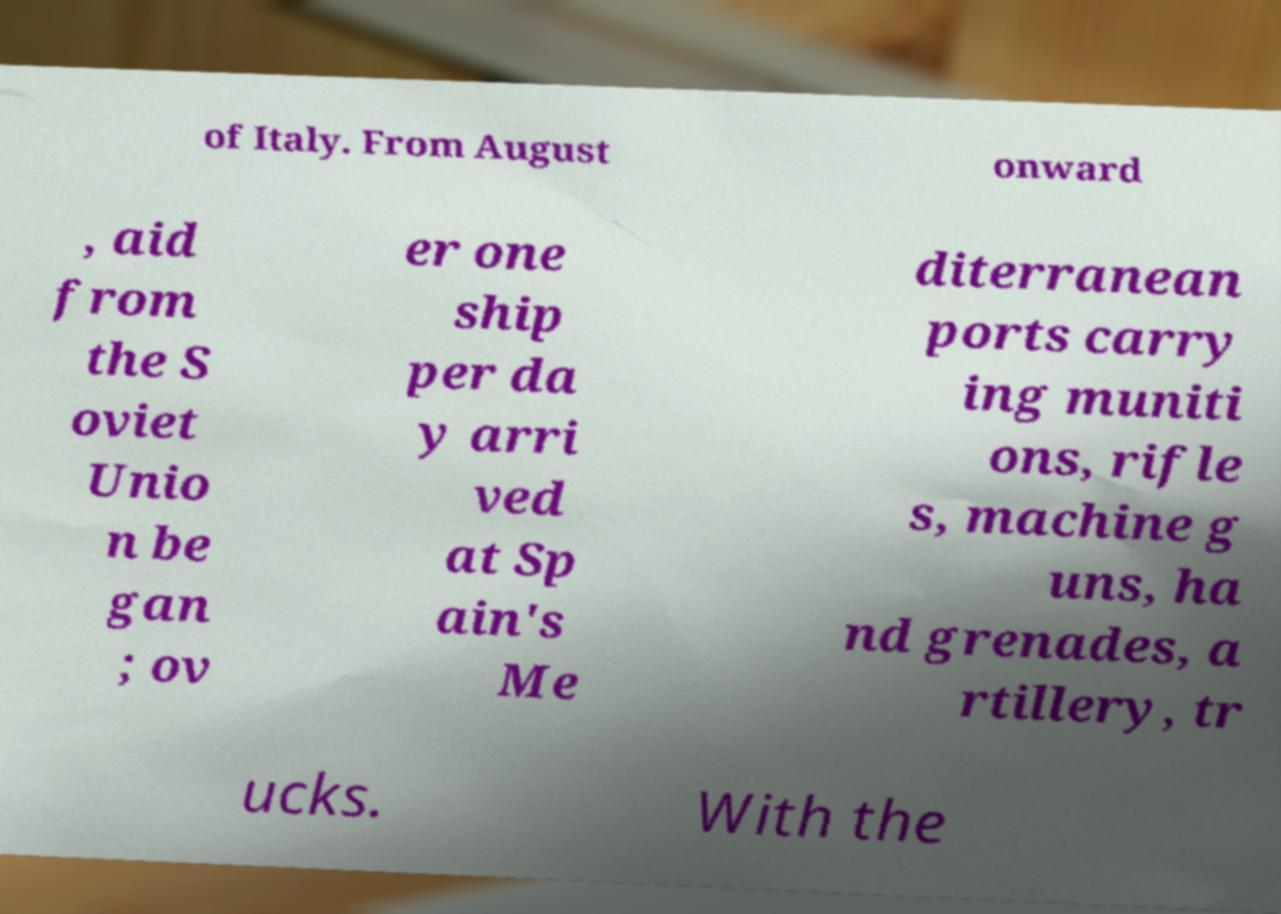I need the written content from this picture converted into text. Can you do that? of Italy. From August onward , aid from the S oviet Unio n be gan ; ov er one ship per da y arri ved at Sp ain's Me diterranean ports carry ing muniti ons, rifle s, machine g uns, ha nd grenades, a rtillery, tr ucks. With the 